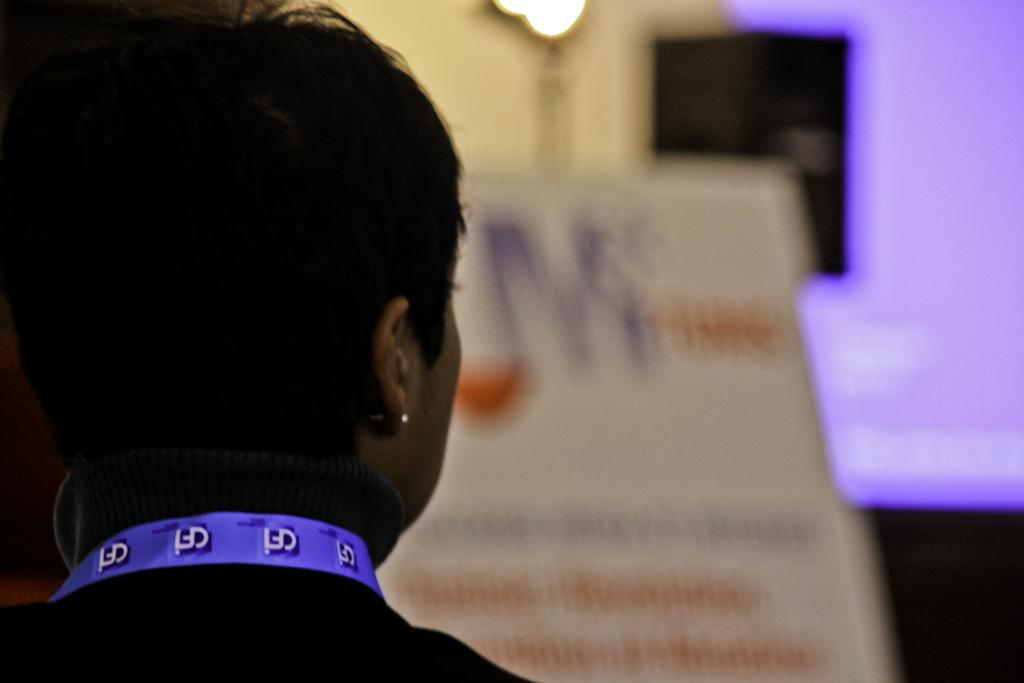Who is on the left side of the image? There is a lady on the left side of the image. What is in the center of the image? There is a poster in the center of the image. What is at the top side of the image? There is a lamp at the top side of the image. How does the lady control the pig in the image? There is no pig present in the image, so the lady cannot control a pig. What type of pipe is visible in the image? There is no pipe present in the image. 